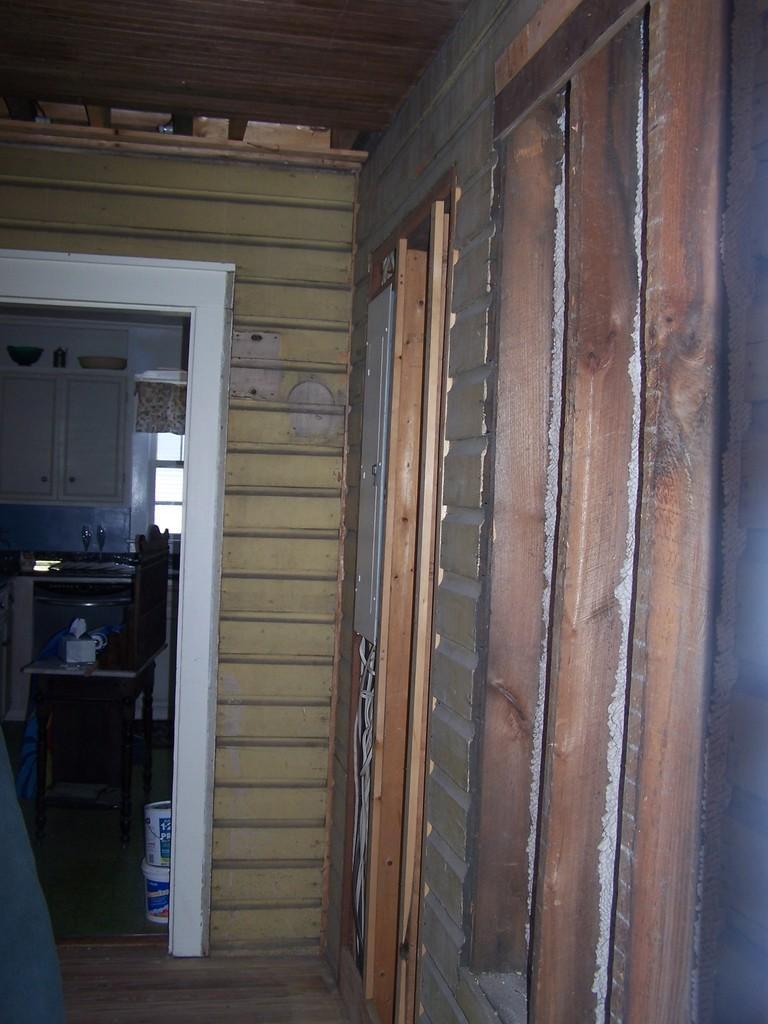In one or two sentences, can you explain what this image depicts? In this picture we can see a wall,chair,cupboard and window. 